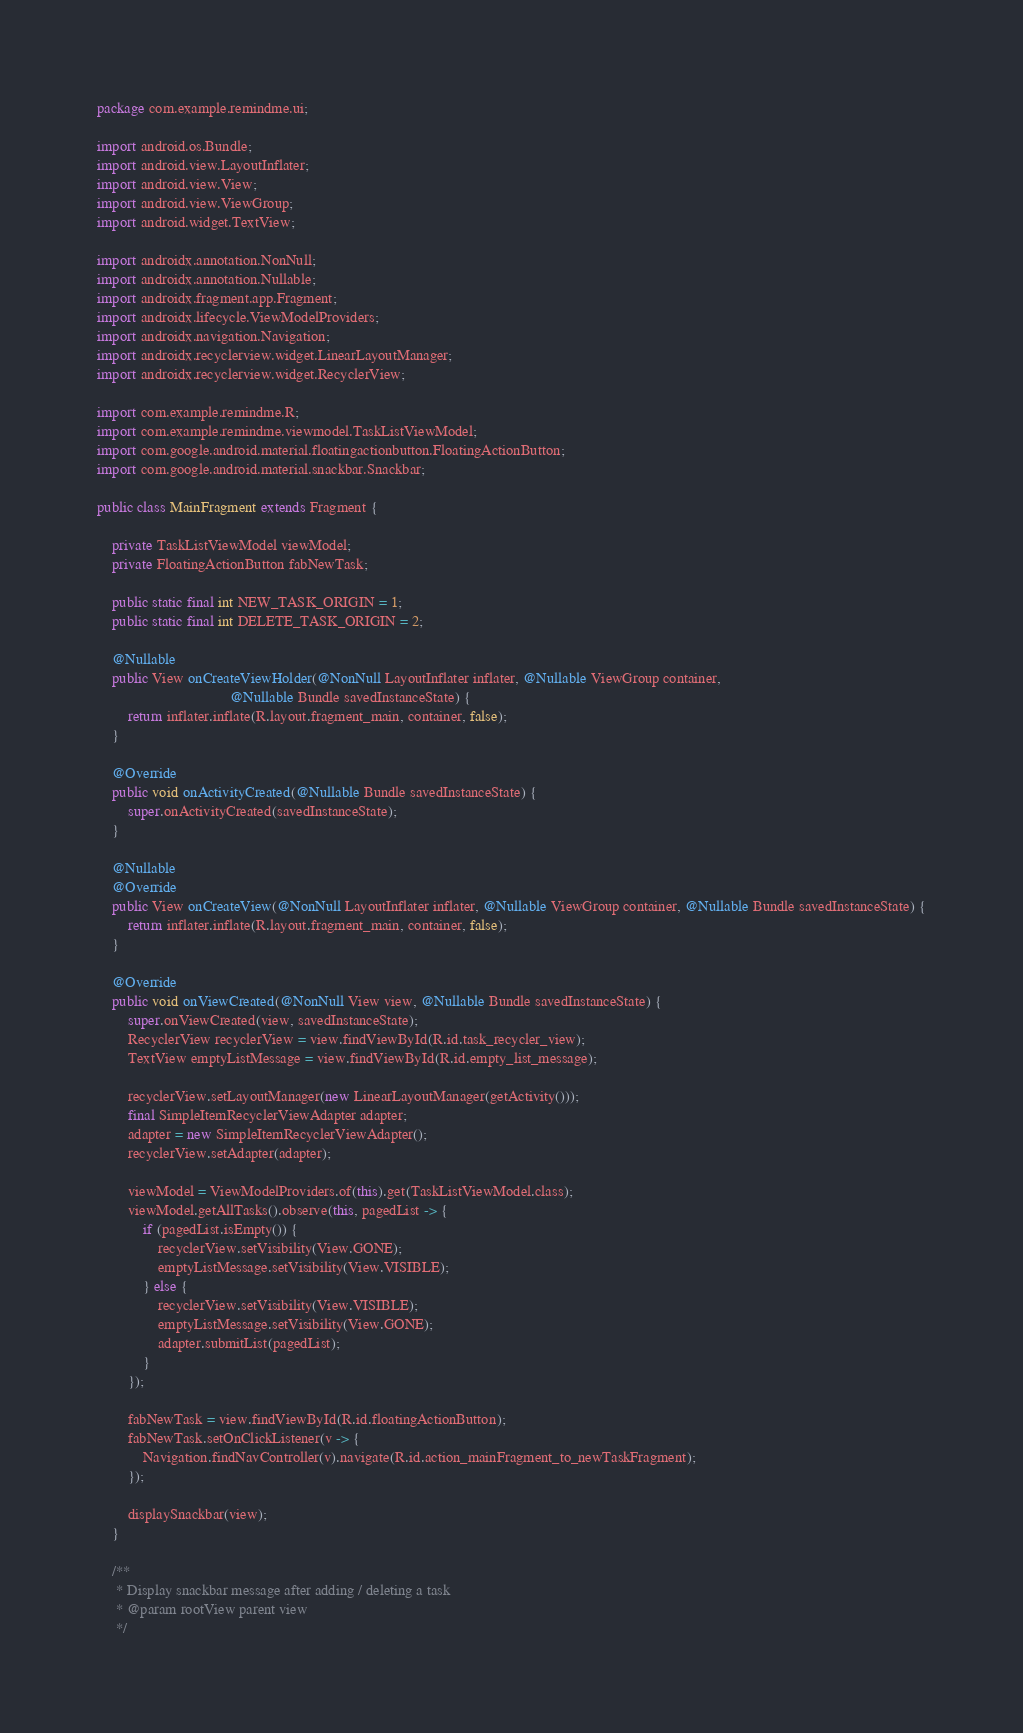Convert code to text. <code><loc_0><loc_0><loc_500><loc_500><_Java_>package com.example.remindme.ui;

import android.os.Bundle;
import android.view.LayoutInflater;
import android.view.View;
import android.view.ViewGroup;
import android.widget.TextView;

import androidx.annotation.NonNull;
import androidx.annotation.Nullable;
import androidx.fragment.app.Fragment;
import androidx.lifecycle.ViewModelProviders;
import androidx.navigation.Navigation;
import androidx.recyclerview.widget.LinearLayoutManager;
import androidx.recyclerview.widget.RecyclerView;

import com.example.remindme.R;
import com.example.remindme.viewmodel.TaskListViewModel;
import com.google.android.material.floatingactionbutton.FloatingActionButton;
import com.google.android.material.snackbar.Snackbar;

public class MainFragment extends Fragment {

    private TaskListViewModel viewModel;
    private FloatingActionButton fabNewTask;

    public static final int NEW_TASK_ORIGIN = 1;
    public static final int DELETE_TASK_ORIGIN = 2;

    @Nullable
    public View onCreateViewHolder(@NonNull LayoutInflater inflater, @Nullable ViewGroup container,
                                   @Nullable Bundle savedInstanceState) {
        return inflater.inflate(R.layout.fragment_main, container, false);
    }

    @Override
    public void onActivityCreated(@Nullable Bundle savedInstanceState) {
        super.onActivityCreated(savedInstanceState);
    }

    @Nullable
    @Override
    public View onCreateView(@NonNull LayoutInflater inflater, @Nullable ViewGroup container, @Nullable Bundle savedInstanceState) {
        return inflater.inflate(R.layout.fragment_main, container, false);
    }

    @Override
    public void onViewCreated(@NonNull View view, @Nullable Bundle savedInstanceState) {
        super.onViewCreated(view, savedInstanceState);
        RecyclerView recyclerView = view.findViewById(R.id.task_recycler_view);
        TextView emptyListMessage = view.findViewById(R.id.empty_list_message);

        recyclerView.setLayoutManager(new LinearLayoutManager(getActivity()));
        final SimpleItemRecyclerViewAdapter adapter;
        adapter = new SimpleItemRecyclerViewAdapter();
        recyclerView.setAdapter(adapter);

        viewModel = ViewModelProviders.of(this).get(TaskListViewModel.class);
        viewModel.getAllTasks().observe(this, pagedList -> {
            if (pagedList.isEmpty()) {
                recyclerView.setVisibility(View.GONE);
                emptyListMessage.setVisibility(View.VISIBLE);
            } else {
                recyclerView.setVisibility(View.VISIBLE);
                emptyListMessage.setVisibility(View.GONE);
                adapter.submitList(pagedList);
            }
        });

        fabNewTask = view.findViewById(R.id.floatingActionButton);
        fabNewTask.setOnClickListener(v -> {
            Navigation.findNavController(v).navigate(R.id.action_mainFragment_to_newTaskFragment);
        });

        displaySnackbar(view);
    }

    /**
     * Display snackbar message after adding / deleting a task
     * @param rootView parent view
     */</code> 